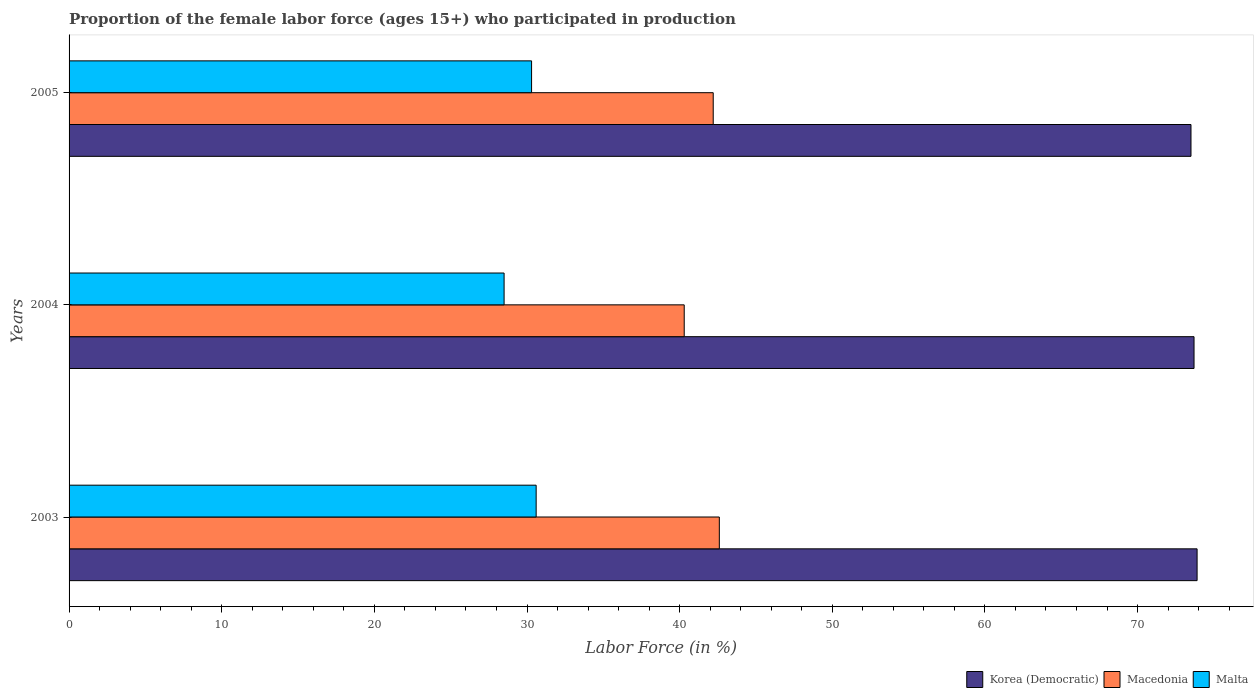How many different coloured bars are there?
Your answer should be very brief. 3. How many groups of bars are there?
Offer a very short reply. 3. In how many cases, is the number of bars for a given year not equal to the number of legend labels?
Give a very brief answer. 0. What is the proportion of the female labor force who participated in production in Macedonia in 2005?
Offer a terse response. 42.2. Across all years, what is the maximum proportion of the female labor force who participated in production in Korea (Democratic)?
Your answer should be very brief. 73.9. Across all years, what is the minimum proportion of the female labor force who participated in production in Macedonia?
Keep it short and to the point. 40.3. In which year was the proportion of the female labor force who participated in production in Korea (Democratic) maximum?
Provide a short and direct response. 2003. In which year was the proportion of the female labor force who participated in production in Malta minimum?
Ensure brevity in your answer.  2004. What is the total proportion of the female labor force who participated in production in Korea (Democratic) in the graph?
Keep it short and to the point. 221.1. What is the difference between the proportion of the female labor force who participated in production in Macedonia in 2004 and that in 2005?
Provide a short and direct response. -1.9. What is the difference between the proportion of the female labor force who participated in production in Malta in 2004 and the proportion of the female labor force who participated in production in Korea (Democratic) in 2003?
Make the answer very short. -45.4. What is the average proportion of the female labor force who participated in production in Malta per year?
Your answer should be very brief. 29.8. In the year 2005, what is the difference between the proportion of the female labor force who participated in production in Korea (Democratic) and proportion of the female labor force who participated in production in Macedonia?
Make the answer very short. 31.3. What is the ratio of the proportion of the female labor force who participated in production in Macedonia in 2003 to that in 2004?
Make the answer very short. 1.06. Is the difference between the proportion of the female labor force who participated in production in Korea (Democratic) in 2003 and 2005 greater than the difference between the proportion of the female labor force who participated in production in Macedonia in 2003 and 2005?
Offer a terse response. Yes. What is the difference between the highest and the second highest proportion of the female labor force who participated in production in Korea (Democratic)?
Provide a succinct answer. 0.2. What is the difference between the highest and the lowest proportion of the female labor force who participated in production in Korea (Democratic)?
Your answer should be very brief. 0.4. Is the sum of the proportion of the female labor force who participated in production in Korea (Democratic) in 2003 and 2004 greater than the maximum proportion of the female labor force who participated in production in Malta across all years?
Your response must be concise. Yes. What does the 3rd bar from the top in 2005 represents?
Provide a short and direct response. Korea (Democratic). What does the 2nd bar from the bottom in 2004 represents?
Give a very brief answer. Macedonia. Is it the case that in every year, the sum of the proportion of the female labor force who participated in production in Malta and proportion of the female labor force who participated in production in Korea (Democratic) is greater than the proportion of the female labor force who participated in production in Macedonia?
Give a very brief answer. Yes. Are all the bars in the graph horizontal?
Offer a terse response. Yes. What is the difference between two consecutive major ticks on the X-axis?
Your answer should be very brief. 10. Are the values on the major ticks of X-axis written in scientific E-notation?
Your answer should be compact. No. Does the graph contain any zero values?
Make the answer very short. No. Where does the legend appear in the graph?
Offer a terse response. Bottom right. What is the title of the graph?
Keep it short and to the point. Proportion of the female labor force (ages 15+) who participated in production. What is the label or title of the Y-axis?
Ensure brevity in your answer.  Years. What is the Labor Force (in %) of Korea (Democratic) in 2003?
Your response must be concise. 73.9. What is the Labor Force (in %) of Macedonia in 2003?
Make the answer very short. 42.6. What is the Labor Force (in %) of Malta in 2003?
Ensure brevity in your answer.  30.6. What is the Labor Force (in %) in Korea (Democratic) in 2004?
Offer a terse response. 73.7. What is the Labor Force (in %) in Macedonia in 2004?
Make the answer very short. 40.3. What is the Labor Force (in %) of Malta in 2004?
Your answer should be very brief. 28.5. What is the Labor Force (in %) in Korea (Democratic) in 2005?
Your response must be concise. 73.5. What is the Labor Force (in %) of Macedonia in 2005?
Give a very brief answer. 42.2. What is the Labor Force (in %) of Malta in 2005?
Your answer should be very brief. 30.3. Across all years, what is the maximum Labor Force (in %) in Korea (Democratic)?
Provide a succinct answer. 73.9. Across all years, what is the maximum Labor Force (in %) of Macedonia?
Provide a succinct answer. 42.6. Across all years, what is the maximum Labor Force (in %) in Malta?
Provide a short and direct response. 30.6. Across all years, what is the minimum Labor Force (in %) of Korea (Democratic)?
Keep it short and to the point. 73.5. Across all years, what is the minimum Labor Force (in %) in Macedonia?
Make the answer very short. 40.3. What is the total Labor Force (in %) in Korea (Democratic) in the graph?
Your answer should be very brief. 221.1. What is the total Labor Force (in %) of Macedonia in the graph?
Your answer should be compact. 125.1. What is the total Labor Force (in %) of Malta in the graph?
Make the answer very short. 89.4. What is the difference between the Labor Force (in %) in Macedonia in 2003 and that in 2004?
Your response must be concise. 2.3. What is the difference between the Labor Force (in %) in Malta in 2003 and that in 2004?
Make the answer very short. 2.1. What is the difference between the Labor Force (in %) of Macedonia in 2003 and that in 2005?
Your answer should be very brief. 0.4. What is the difference between the Labor Force (in %) in Malta in 2003 and that in 2005?
Offer a very short reply. 0.3. What is the difference between the Labor Force (in %) in Korea (Democratic) in 2004 and that in 2005?
Give a very brief answer. 0.2. What is the difference between the Labor Force (in %) in Macedonia in 2004 and that in 2005?
Offer a terse response. -1.9. What is the difference between the Labor Force (in %) in Korea (Democratic) in 2003 and the Labor Force (in %) in Macedonia in 2004?
Offer a very short reply. 33.6. What is the difference between the Labor Force (in %) in Korea (Democratic) in 2003 and the Labor Force (in %) in Malta in 2004?
Make the answer very short. 45.4. What is the difference between the Labor Force (in %) in Korea (Democratic) in 2003 and the Labor Force (in %) in Macedonia in 2005?
Give a very brief answer. 31.7. What is the difference between the Labor Force (in %) of Korea (Democratic) in 2003 and the Labor Force (in %) of Malta in 2005?
Offer a very short reply. 43.6. What is the difference between the Labor Force (in %) in Macedonia in 2003 and the Labor Force (in %) in Malta in 2005?
Provide a succinct answer. 12.3. What is the difference between the Labor Force (in %) of Korea (Democratic) in 2004 and the Labor Force (in %) of Macedonia in 2005?
Your response must be concise. 31.5. What is the difference between the Labor Force (in %) in Korea (Democratic) in 2004 and the Labor Force (in %) in Malta in 2005?
Provide a short and direct response. 43.4. What is the difference between the Labor Force (in %) of Macedonia in 2004 and the Labor Force (in %) of Malta in 2005?
Your response must be concise. 10. What is the average Labor Force (in %) in Korea (Democratic) per year?
Provide a short and direct response. 73.7. What is the average Labor Force (in %) of Macedonia per year?
Ensure brevity in your answer.  41.7. What is the average Labor Force (in %) of Malta per year?
Provide a short and direct response. 29.8. In the year 2003, what is the difference between the Labor Force (in %) in Korea (Democratic) and Labor Force (in %) in Macedonia?
Offer a terse response. 31.3. In the year 2003, what is the difference between the Labor Force (in %) of Korea (Democratic) and Labor Force (in %) of Malta?
Keep it short and to the point. 43.3. In the year 2004, what is the difference between the Labor Force (in %) in Korea (Democratic) and Labor Force (in %) in Macedonia?
Your answer should be compact. 33.4. In the year 2004, what is the difference between the Labor Force (in %) of Korea (Democratic) and Labor Force (in %) of Malta?
Ensure brevity in your answer.  45.2. In the year 2005, what is the difference between the Labor Force (in %) of Korea (Democratic) and Labor Force (in %) of Macedonia?
Your answer should be very brief. 31.3. In the year 2005, what is the difference between the Labor Force (in %) of Korea (Democratic) and Labor Force (in %) of Malta?
Your answer should be very brief. 43.2. What is the ratio of the Labor Force (in %) in Macedonia in 2003 to that in 2004?
Provide a succinct answer. 1.06. What is the ratio of the Labor Force (in %) of Malta in 2003 to that in 2004?
Make the answer very short. 1.07. What is the ratio of the Labor Force (in %) in Korea (Democratic) in 2003 to that in 2005?
Your answer should be very brief. 1.01. What is the ratio of the Labor Force (in %) in Macedonia in 2003 to that in 2005?
Offer a very short reply. 1.01. What is the ratio of the Labor Force (in %) of Malta in 2003 to that in 2005?
Provide a short and direct response. 1.01. What is the ratio of the Labor Force (in %) of Macedonia in 2004 to that in 2005?
Ensure brevity in your answer.  0.95. What is the ratio of the Labor Force (in %) of Malta in 2004 to that in 2005?
Provide a short and direct response. 0.94. What is the difference between the highest and the second highest Labor Force (in %) in Malta?
Offer a very short reply. 0.3. 